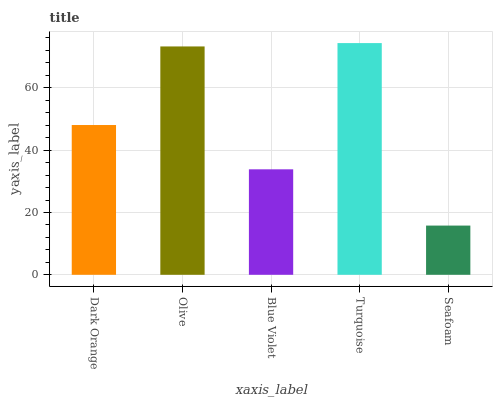Is Seafoam the minimum?
Answer yes or no. Yes. Is Turquoise the maximum?
Answer yes or no. Yes. Is Olive the minimum?
Answer yes or no. No. Is Olive the maximum?
Answer yes or no. No. Is Olive greater than Dark Orange?
Answer yes or no. Yes. Is Dark Orange less than Olive?
Answer yes or no. Yes. Is Dark Orange greater than Olive?
Answer yes or no. No. Is Olive less than Dark Orange?
Answer yes or no. No. Is Dark Orange the high median?
Answer yes or no. Yes. Is Dark Orange the low median?
Answer yes or no. Yes. Is Turquoise the high median?
Answer yes or no. No. Is Turquoise the low median?
Answer yes or no. No. 